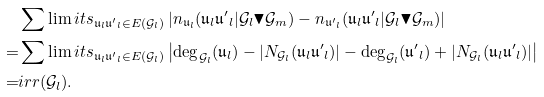Convert formula to latex. <formula><loc_0><loc_0><loc_500><loc_500>& \sum \lim i t s _ { \mathfrak { u } _ { l } \mathfrak { u ^ { \prime } } _ { l } \in E ( \mathcal { G } _ { l } ) } \left | n _ { \mathfrak { u } _ { l } } ( \mathfrak { u } _ { l } \mathfrak { u ^ { \prime } } _ { l } | \mathcal { G } _ { l } \blacktriangledown \mathcal { G } _ { m } ) - n _ { \mathfrak { u ^ { \prime } } _ { l } } ( \mathfrak { u } _ { l } \mathfrak { u ^ { \prime } } _ { l } | \mathcal { G } _ { l } \blacktriangledown \mathcal { G } _ { m } ) \right | \\ = & \sum \lim i t s _ { \mathfrak { u } _ { l } \mathfrak { u ^ { \prime } } _ { l } \in E ( \mathcal { G } _ { l } ) } \left | \deg _ { \mathcal { G } _ { l } } ( \mathfrak { u } _ { l } ) - | N _ { \mathcal { G } _ { l } } ( \mathfrak { u } _ { l } \mathfrak { u ^ { \prime } } _ { l } ) | - \deg _ { \mathcal { G } _ { l } } ( \mathfrak { u ^ { \prime } } _ { l } ) + | N _ { \mathcal { G } _ { l } } ( \mathfrak { u } _ { l } \mathfrak { u ^ { \prime } } _ { l } ) | \right | \\ = & i r r ( \mathcal { G } _ { l } ) .</formula> 